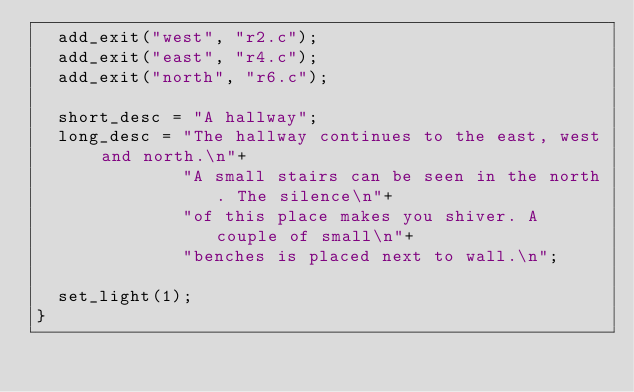<code> <loc_0><loc_0><loc_500><loc_500><_C_>  add_exit("west", "r2.c");
  add_exit("east", "r4.c");
  add_exit("north", "r6.c");

  short_desc = "A hallway";
  long_desc = "The hallway continues to the east, west and north.\n"+
              "A small stairs can be seen in the north. The silence\n"+
              "of this place makes you shiver. A couple of small\n"+
              "benches is placed next to wall.\n";
 
  set_light(1);
}
</code> 